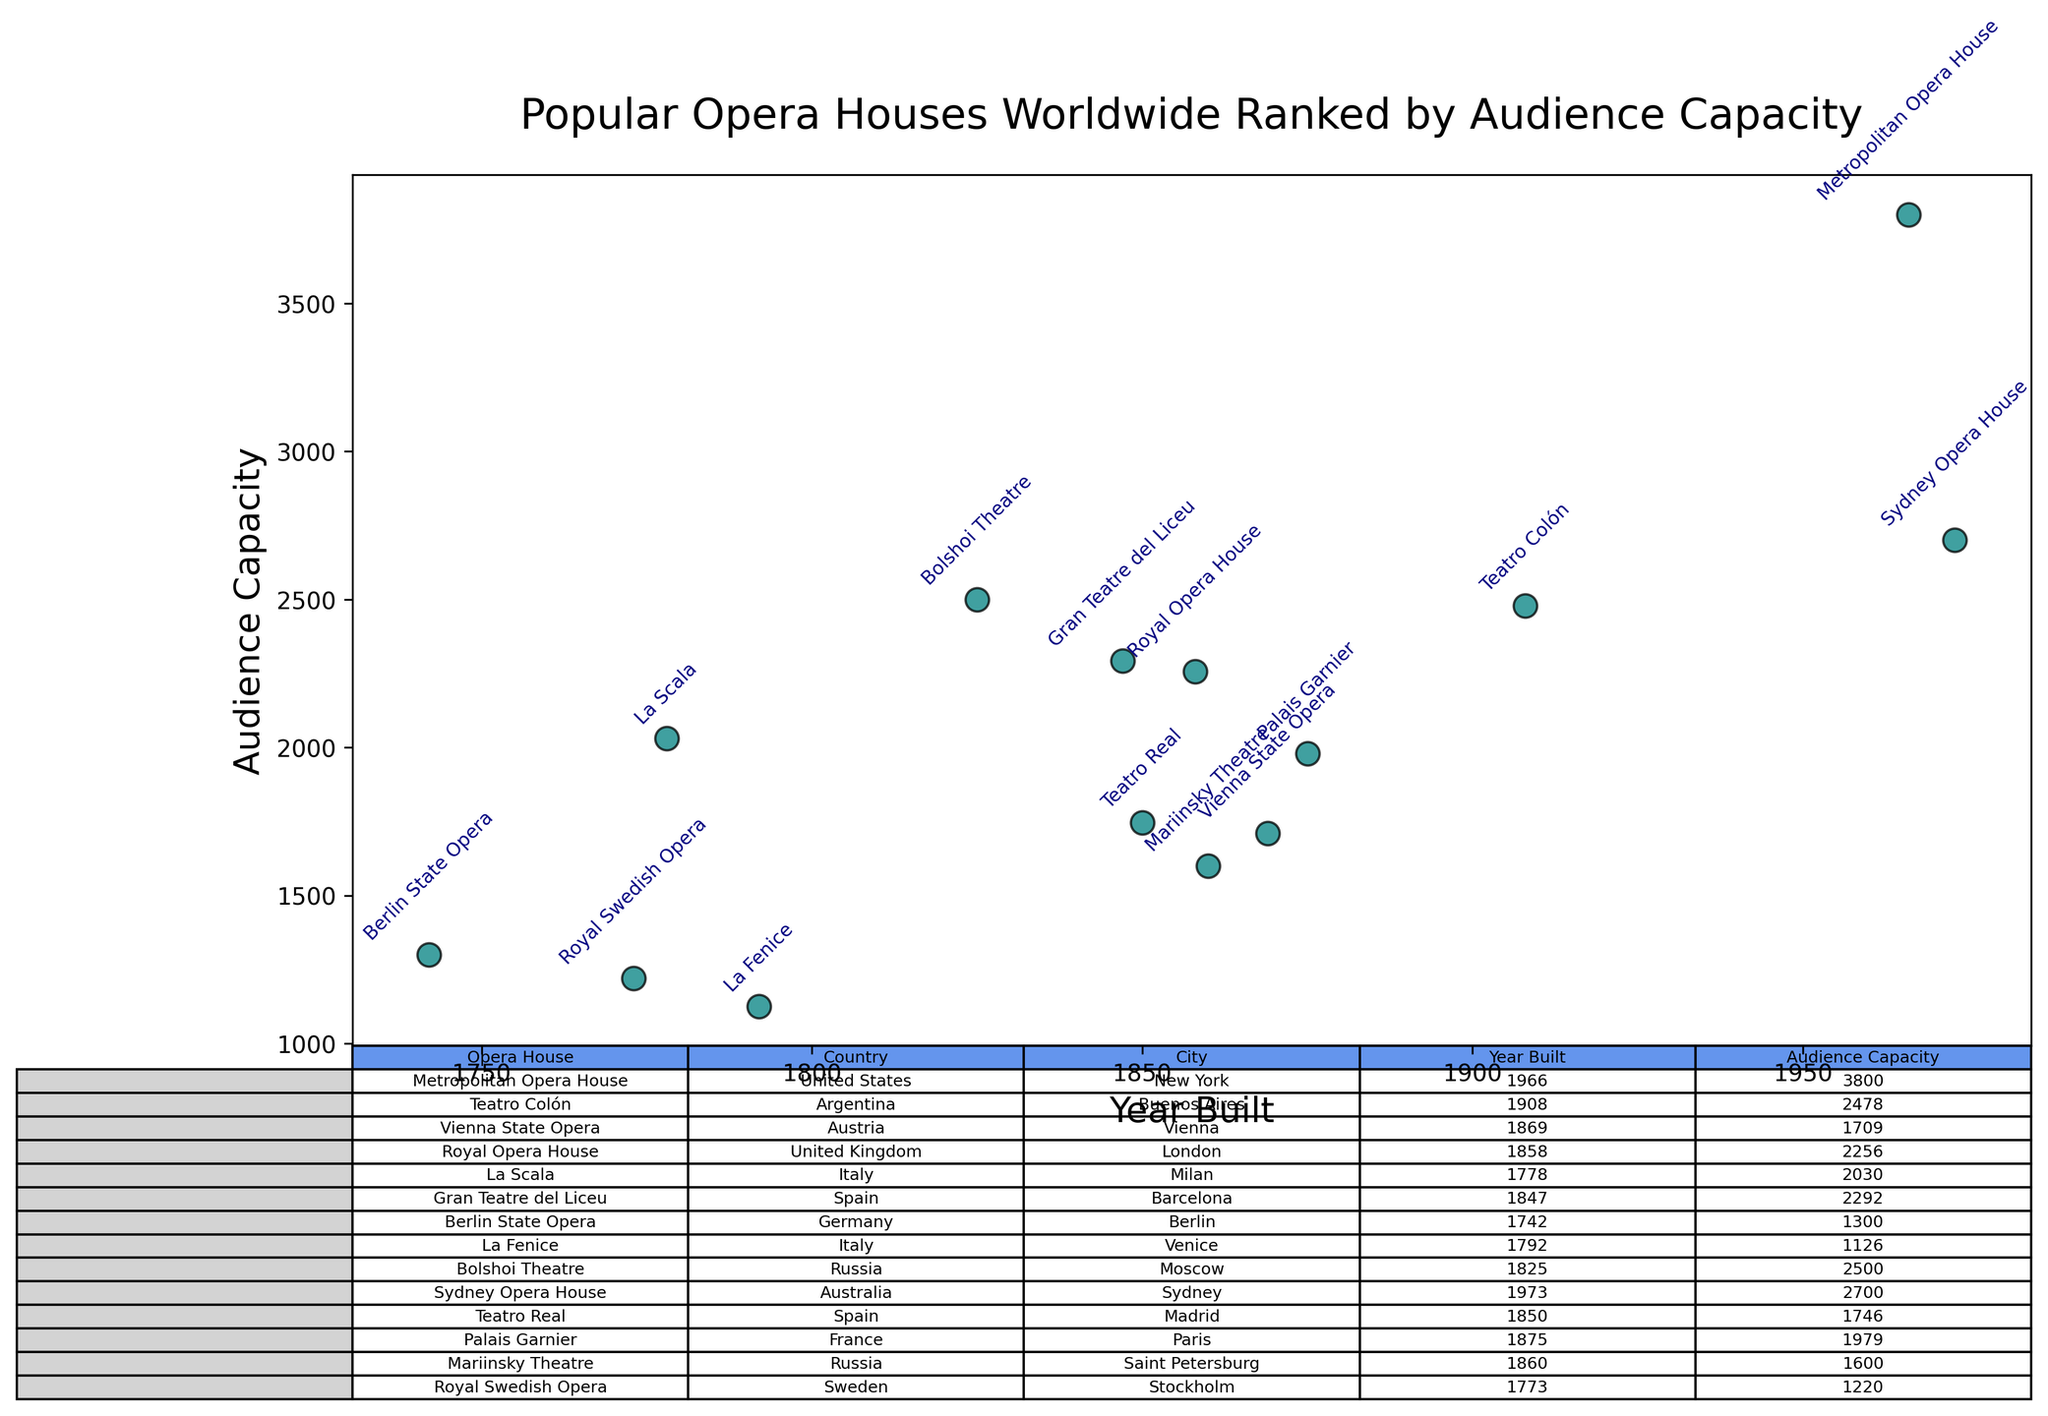Which opera house has the largest audience capacity? Refer to the figure: Metropolitan Opera House in the United States has the largest audience capacity, as shown by its highest data point in terms of audience capacity.
Answer: Metropolitan Opera House Which opera house was built most recently? Look for the highest year in the 'Year Built' column: The Sydney Opera House in Australia is the most recently built, indicated by the year 1973.
Answer: Sydney Opera House How many opera houses were built before 1800? Count the data points with 'Year Built' less than 1800: Berlin State Opera (1742), La Scala (1778), La Fenice (1792), and Royal Swedish Opera (1773). So, there are four.
Answer: 4 Which country has the most opera houses in this list? Count the occurrences of each country in the 'Country' column: Spain (2), Russia (2), Italy (2), and the rest are unique. Thus, Italy, Russia, and Spain each have 2.
Answer: Italy, Russia, Spain What is the combined audience capacity of all opera houses built in the 19th century (1800-1899)? Sum the audience capacities for opera houses built between 1800 and 1899: Teatro Colón (2478), Royal Opera House (2256), Gran Teatre del Liceu (2292), Bolshoi Theatre (2500), Palais Garnier (1979), Mariinsky Theatre (1600). So, the combined capacity is 2478 + 2256 + 2292 + 2500 + 1979 + 1600 = 13105.
Answer: 13105 Which city is home to the opera house with the second largest audience capacity? Identify the second largest value in 'Audience Capacity' and match it to its city: The Bolshoi Theatre in Moscow has the second largest audience capacity of 2500.
Answer: Moscow What is the median year in which these opera houses were built? Sort the 'Year Built' data and find the middle value: Sorted years are [1742, 1773, 1778, 1792, 1825, 1847, 1850, 1858, 1860, 1869, 1875, 1908, 1966, 1973]. The median values are 1858 and 1860, and the median year is the average: (1858 + 1860) / 2 = 1859.
Answer: 1859 Which opera house has the smallest audience capacity, and what is that capacity? Identify the smallest value in 'Audience Capacity' and its corresponding opera house: La Fenice in Italy has the smallest audience capacity with 1126 seats.
Answer: La Fenice, 1126 